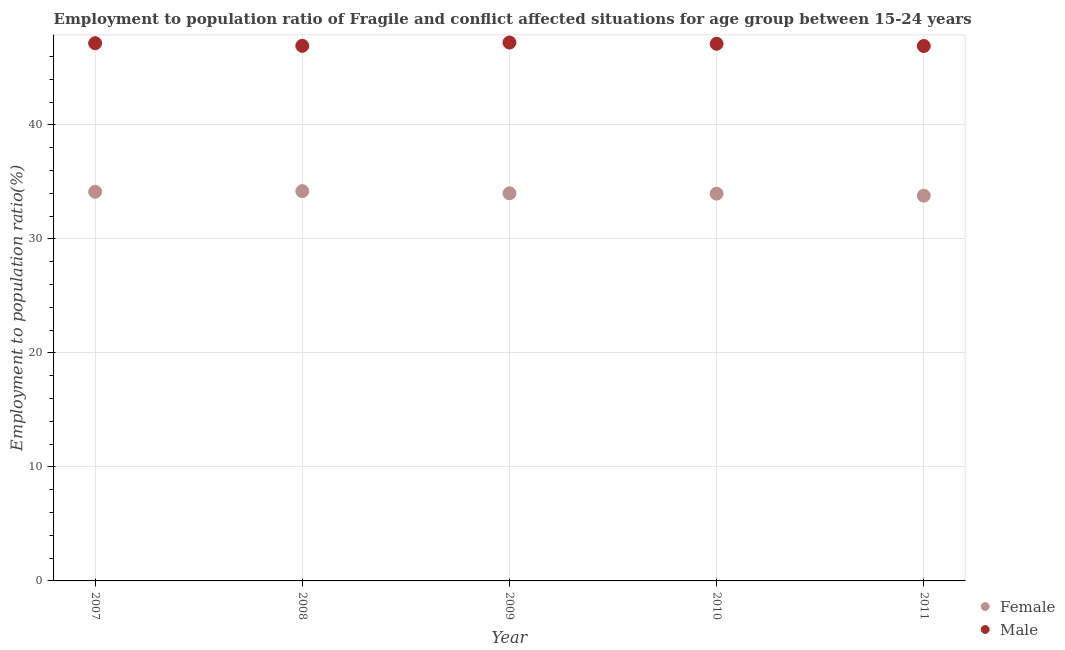How many different coloured dotlines are there?
Provide a short and direct response. 2. What is the employment to population ratio(male) in 2010?
Your response must be concise. 47.11. Across all years, what is the maximum employment to population ratio(female)?
Make the answer very short. 34.19. Across all years, what is the minimum employment to population ratio(male)?
Give a very brief answer. 46.92. In which year was the employment to population ratio(female) maximum?
Offer a terse response. 2008. What is the total employment to population ratio(male) in the graph?
Provide a short and direct response. 235.35. What is the difference between the employment to population ratio(female) in 2008 and that in 2011?
Offer a terse response. 0.4. What is the difference between the employment to population ratio(female) in 2011 and the employment to population ratio(male) in 2007?
Ensure brevity in your answer.  -13.37. What is the average employment to population ratio(male) per year?
Keep it short and to the point. 47.07. In the year 2007, what is the difference between the employment to population ratio(male) and employment to population ratio(female)?
Provide a short and direct response. 13.03. In how many years, is the employment to population ratio(female) greater than 2 %?
Your response must be concise. 5. What is the ratio of the employment to population ratio(female) in 2010 to that in 2011?
Provide a short and direct response. 1.01. Is the difference between the employment to population ratio(female) in 2009 and 2011 greater than the difference between the employment to population ratio(male) in 2009 and 2011?
Give a very brief answer. No. What is the difference between the highest and the second highest employment to population ratio(female)?
Provide a succinct answer. 0.05. What is the difference between the highest and the lowest employment to population ratio(male)?
Offer a terse response. 0.3. Does the employment to population ratio(female) monotonically increase over the years?
Offer a terse response. No. Is the employment to population ratio(male) strictly less than the employment to population ratio(female) over the years?
Your response must be concise. No. How many dotlines are there?
Your response must be concise. 2. Does the graph contain any zero values?
Give a very brief answer. No. Does the graph contain grids?
Your answer should be very brief. Yes. Where does the legend appear in the graph?
Give a very brief answer. Bottom right. How many legend labels are there?
Keep it short and to the point. 2. How are the legend labels stacked?
Offer a very short reply. Vertical. What is the title of the graph?
Give a very brief answer. Employment to population ratio of Fragile and conflict affected situations for age group between 15-24 years. What is the label or title of the Y-axis?
Offer a very short reply. Employment to population ratio(%). What is the Employment to population ratio(%) of Female in 2007?
Offer a terse response. 34.13. What is the Employment to population ratio(%) in Male in 2007?
Keep it short and to the point. 47.16. What is the Employment to population ratio(%) in Female in 2008?
Keep it short and to the point. 34.19. What is the Employment to population ratio(%) of Male in 2008?
Your answer should be very brief. 46.93. What is the Employment to population ratio(%) in Female in 2009?
Keep it short and to the point. 34. What is the Employment to population ratio(%) of Male in 2009?
Your response must be concise. 47.22. What is the Employment to population ratio(%) of Female in 2010?
Provide a succinct answer. 33.97. What is the Employment to population ratio(%) in Male in 2010?
Your response must be concise. 47.11. What is the Employment to population ratio(%) in Female in 2011?
Offer a terse response. 33.79. What is the Employment to population ratio(%) of Male in 2011?
Your answer should be compact. 46.92. Across all years, what is the maximum Employment to population ratio(%) in Female?
Your answer should be compact. 34.19. Across all years, what is the maximum Employment to population ratio(%) of Male?
Give a very brief answer. 47.22. Across all years, what is the minimum Employment to population ratio(%) of Female?
Offer a terse response. 33.79. Across all years, what is the minimum Employment to population ratio(%) of Male?
Your answer should be compact. 46.92. What is the total Employment to population ratio(%) of Female in the graph?
Offer a very short reply. 170.08. What is the total Employment to population ratio(%) in Male in the graph?
Ensure brevity in your answer.  235.35. What is the difference between the Employment to population ratio(%) of Female in 2007 and that in 2008?
Give a very brief answer. -0.05. What is the difference between the Employment to population ratio(%) of Male in 2007 and that in 2008?
Your response must be concise. 0.23. What is the difference between the Employment to population ratio(%) in Female in 2007 and that in 2009?
Ensure brevity in your answer.  0.13. What is the difference between the Employment to population ratio(%) in Male in 2007 and that in 2009?
Ensure brevity in your answer.  -0.06. What is the difference between the Employment to population ratio(%) of Female in 2007 and that in 2010?
Keep it short and to the point. 0.16. What is the difference between the Employment to population ratio(%) of Male in 2007 and that in 2010?
Provide a succinct answer. 0.05. What is the difference between the Employment to population ratio(%) in Female in 2007 and that in 2011?
Your answer should be compact. 0.34. What is the difference between the Employment to population ratio(%) in Male in 2007 and that in 2011?
Your answer should be very brief. 0.25. What is the difference between the Employment to population ratio(%) of Female in 2008 and that in 2009?
Make the answer very short. 0.19. What is the difference between the Employment to population ratio(%) in Male in 2008 and that in 2009?
Offer a terse response. -0.29. What is the difference between the Employment to population ratio(%) in Female in 2008 and that in 2010?
Make the answer very short. 0.22. What is the difference between the Employment to population ratio(%) of Male in 2008 and that in 2010?
Give a very brief answer. -0.18. What is the difference between the Employment to population ratio(%) of Female in 2008 and that in 2011?
Offer a terse response. 0.4. What is the difference between the Employment to population ratio(%) in Male in 2008 and that in 2011?
Keep it short and to the point. 0.01. What is the difference between the Employment to population ratio(%) in Female in 2009 and that in 2010?
Offer a very short reply. 0.03. What is the difference between the Employment to population ratio(%) of Male in 2009 and that in 2010?
Provide a short and direct response. 0.11. What is the difference between the Employment to population ratio(%) in Female in 2009 and that in 2011?
Ensure brevity in your answer.  0.21. What is the difference between the Employment to population ratio(%) of Male in 2009 and that in 2011?
Keep it short and to the point. 0.3. What is the difference between the Employment to population ratio(%) of Female in 2010 and that in 2011?
Offer a very short reply. 0.18. What is the difference between the Employment to population ratio(%) in Male in 2010 and that in 2011?
Your answer should be compact. 0.19. What is the difference between the Employment to population ratio(%) in Female in 2007 and the Employment to population ratio(%) in Male in 2009?
Make the answer very short. -13.09. What is the difference between the Employment to population ratio(%) in Female in 2007 and the Employment to population ratio(%) in Male in 2010?
Keep it short and to the point. -12.98. What is the difference between the Employment to population ratio(%) in Female in 2007 and the Employment to population ratio(%) in Male in 2011?
Provide a succinct answer. -12.79. What is the difference between the Employment to population ratio(%) of Female in 2008 and the Employment to population ratio(%) of Male in 2009?
Offer a very short reply. -13.04. What is the difference between the Employment to population ratio(%) in Female in 2008 and the Employment to population ratio(%) in Male in 2010?
Provide a short and direct response. -12.93. What is the difference between the Employment to population ratio(%) of Female in 2008 and the Employment to population ratio(%) of Male in 2011?
Provide a succinct answer. -12.73. What is the difference between the Employment to population ratio(%) in Female in 2009 and the Employment to population ratio(%) in Male in 2010?
Offer a very short reply. -13.11. What is the difference between the Employment to population ratio(%) of Female in 2009 and the Employment to population ratio(%) of Male in 2011?
Give a very brief answer. -12.92. What is the difference between the Employment to population ratio(%) of Female in 2010 and the Employment to population ratio(%) of Male in 2011?
Provide a succinct answer. -12.95. What is the average Employment to population ratio(%) in Female per year?
Your answer should be very brief. 34.02. What is the average Employment to population ratio(%) of Male per year?
Offer a terse response. 47.07. In the year 2007, what is the difference between the Employment to population ratio(%) of Female and Employment to population ratio(%) of Male?
Offer a very short reply. -13.03. In the year 2008, what is the difference between the Employment to population ratio(%) of Female and Employment to population ratio(%) of Male?
Make the answer very short. -12.75. In the year 2009, what is the difference between the Employment to population ratio(%) of Female and Employment to population ratio(%) of Male?
Provide a succinct answer. -13.22. In the year 2010, what is the difference between the Employment to population ratio(%) of Female and Employment to population ratio(%) of Male?
Offer a very short reply. -13.14. In the year 2011, what is the difference between the Employment to population ratio(%) of Female and Employment to population ratio(%) of Male?
Provide a succinct answer. -13.13. What is the ratio of the Employment to population ratio(%) in Female in 2007 to that in 2008?
Give a very brief answer. 1. What is the ratio of the Employment to population ratio(%) in Male in 2007 to that in 2008?
Your response must be concise. 1. What is the ratio of the Employment to population ratio(%) of Male in 2007 to that in 2009?
Your response must be concise. 1. What is the ratio of the Employment to population ratio(%) of Female in 2007 to that in 2010?
Ensure brevity in your answer.  1. What is the ratio of the Employment to population ratio(%) of Male in 2007 to that in 2010?
Offer a very short reply. 1. What is the ratio of the Employment to population ratio(%) in Female in 2007 to that in 2011?
Provide a succinct answer. 1.01. What is the ratio of the Employment to population ratio(%) in Male in 2008 to that in 2009?
Offer a very short reply. 0.99. What is the ratio of the Employment to population ratio(%) of Female in 2008 to that in 2010?
Keep it short and to the point. 1.01. What is the ratio of the Employment to population ratio(%) in Female in 2008 to that in 2011?
Provide a succinct answer. 1.01. What is the ratio of the Employment to population ratio(%) in Male in 2008 to that in 2011?
Ensure brevity in your answer.  1. What is the ratio of the Employment to population ratio(%) of Female in 2009 to that in 2010?
Your answer should be very brief. 1. What is the ratio of the Employment to population ratio(%) of Male in 2009 to that in 2010?
Provide a succinct answer. 1. What is the ratio of the Employment to population ratio(%) in Male in 2009 to that in 2011?
Offer a terse response. 1.01. What is the ratio of the Employment to population ratio(%) in Female in 2010 to that in 2011?
Keep it short and to the point. 1.01. What is the ratio of the Employment to population ratio(%) in Male in 2010 to that in 2011?
Your answer should be compact. 1. What is the difference between the highest and the second highest Employment to population ratio(%) in Female?
Provide a succinct answer. 0.05. What is the difference between the highest and the second highest Employment to population ratio(%) of Male?
Ensure brevity in your answer.  0.06. What is the difference between the highest and the lowest Employment to population ratio(%) of Female?
Give a very brief answer. 0.4. What is the difference between the highest and the lowest Employment to population ratio(%) in Male?
Your response must be concise. 0.3. 